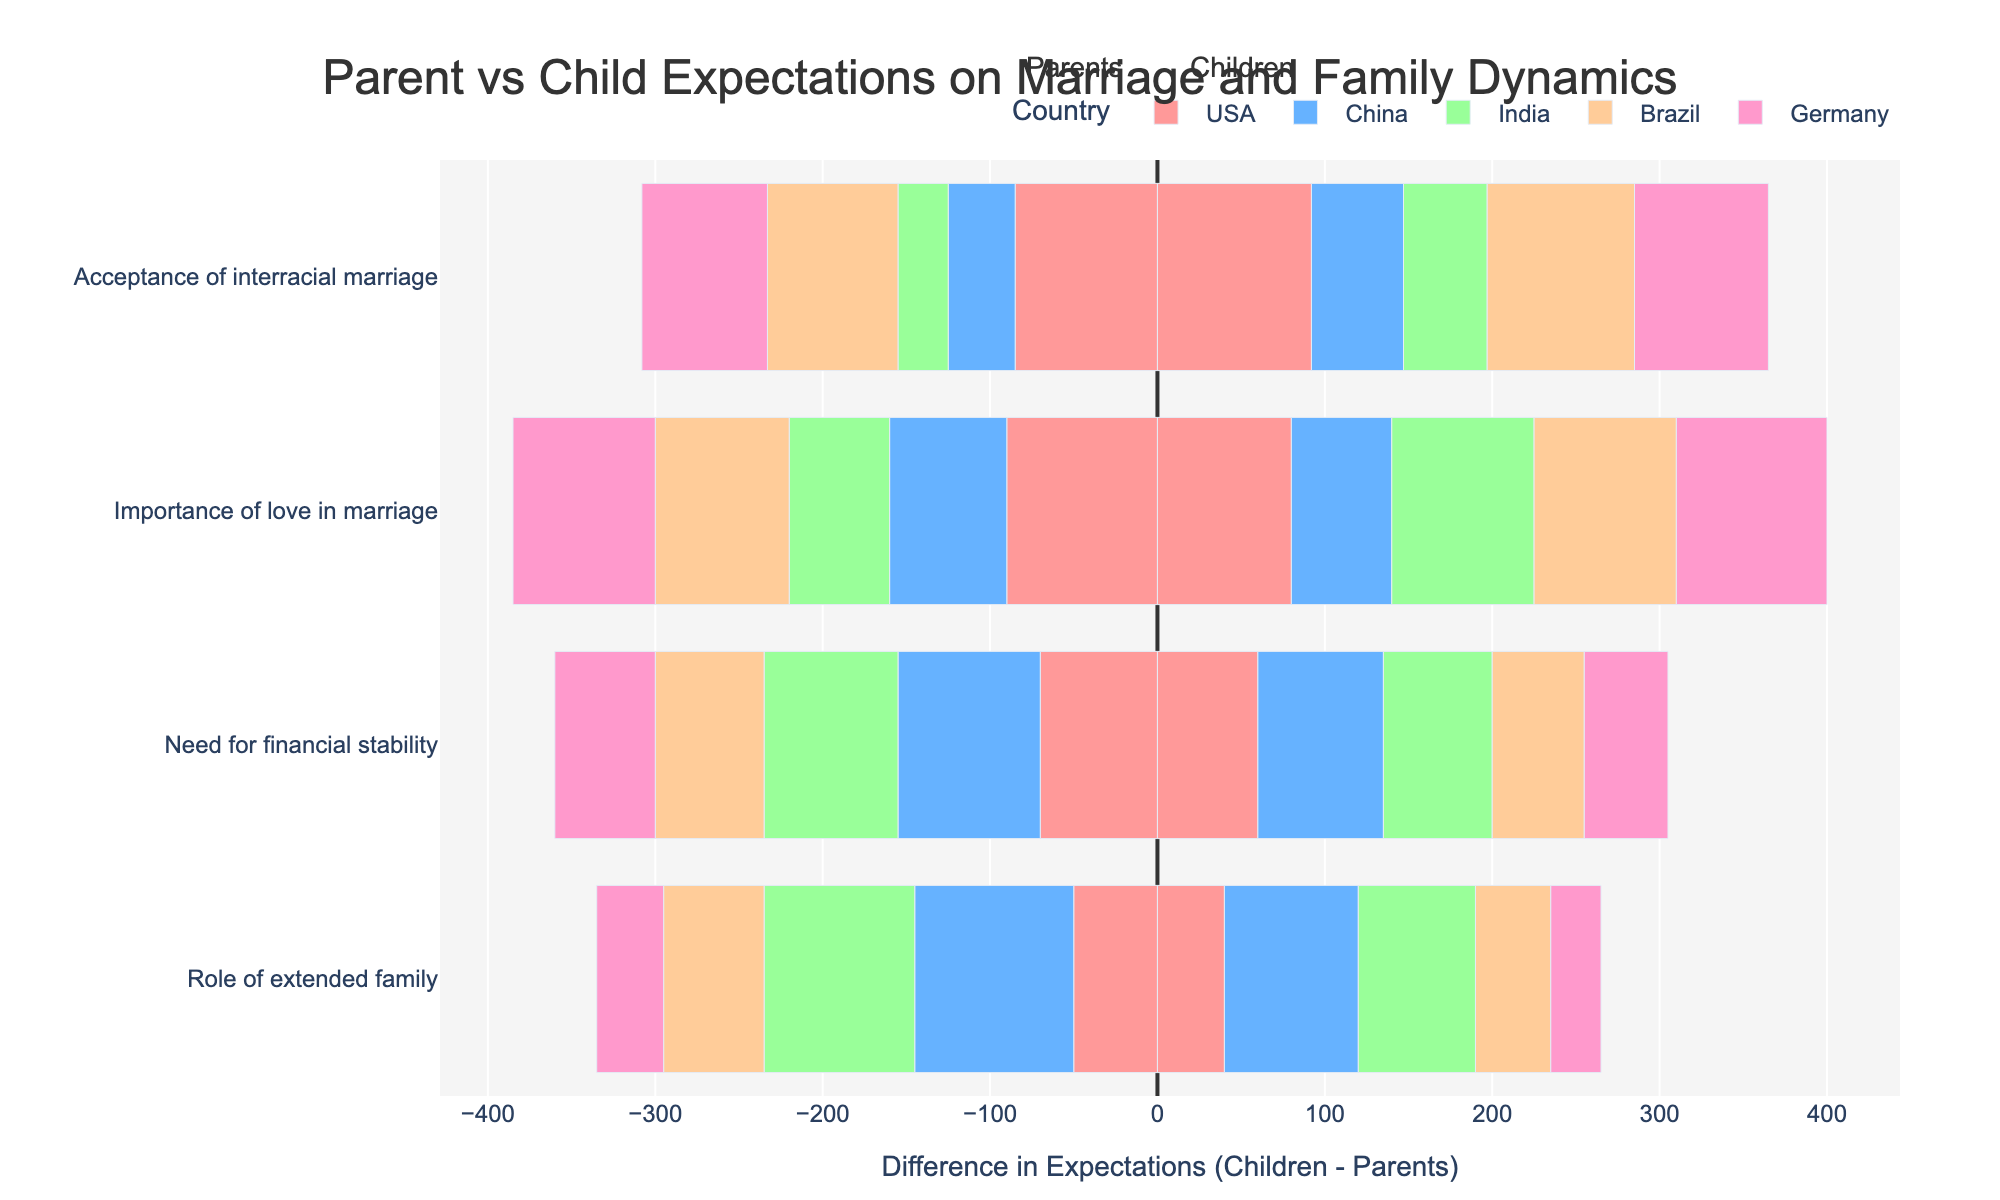Which country has the highest agreement between parents and children on the importance of love in marriage? Look at the divergence of the bars for "Importance of love in marriage" across countries. The smaller the difference, the higher the agreement. The USA has the highest agreement with a difference of 10 (90-80)
Answer: USA Which expectation shows the largest difference in opinions between parents and children in China? Inspect the distance between the parent and child bars within each expectation for China. The "Role of extended family" has the highest difference, with parents at 95 and children at 80, a difference of 15
Answer: Role of extended family Comparing all countries, which shows the highest acceptance of interracial marriage by children? Look at the child bars for "Acceptance of interracial marriage" across all countries. The USA leads with a value of 92
Answer: USA What is the overall trend in the importance of financial stability between parents and children across the countries? Analyze all bars related to "Need for financial stability". Parents consistently value it higher than children in all countries.
Answer: Parents > Children Which countries' children place more importance on love in marriage compared to their parents? Look for bars where the child's value is higher than the parent's in "Importance of love in marriage". India, Brazil, and Germany have children valuing love higher.
Answer: India, Brazil, Germany In Brazil, how do parents' and children's views on the role of the extended family compare? Observe the bars for "Role of extended family" in Brazil. Parents rate it at 60, while children rate it at 45, indicating parents place more importance.
Answer: Parents > Children Which country displays the smallest difference in the need for financial stability between parents and children? Compare the bars in "Need for financial stability" for each country. The smallest difference is seen in Germany (10 units difference: 60 to 50).
Answer: Germany What is the difference in acceptance of interracial marriage between parents in the USA and Germany? Look at the bars for parents in "Acceptance of interracial marriage" for both USA and Germany. USA parents rate it at 85, Germany at 75. The difference is 10.
Answer: 10 How does Germany compare to India in terms of children's acceptance of interracial marriage? Compare the values for "Acceptance of interracial marriage" for children in Germany and India. Germany scores 80, India scores 50, showing Germany values it more by 30.
Answer: Germany > India by 30 Which country has parents that place the highest importance on the role of the extended family? Identify the highest value bar for "Role of extended family" under parents. China stands out with a value of 95.
Answer: China 